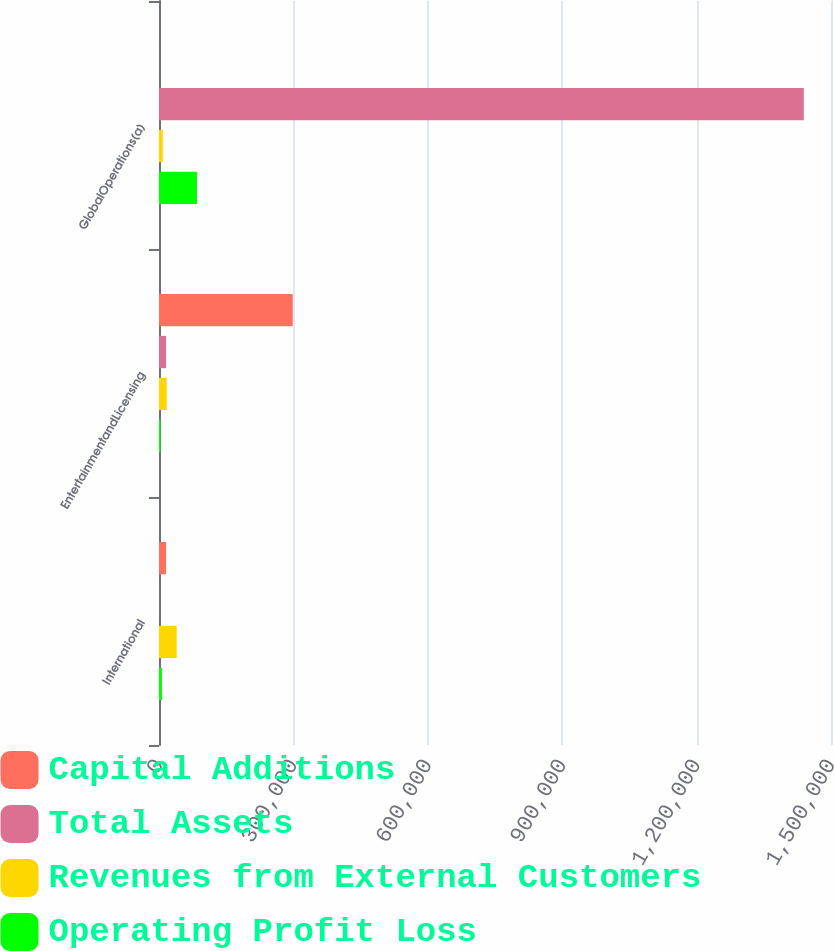Convert chart to OTSL. <chart><loc_0><loc_0><loc_500><loc_500><stacked_bar_chart><ecel><fcel>International<fcel>EntertainmentandLicensing<fcel>GlobalOperations(a)<nl><fcel>Capital Additions<fcel>15796<fcel>298540<fcel>109<nl><fcel>Total Assets<fcel>290<fcel>15796<fcel>1.43929e+06<nl><fcel>Revenues from External Customers<fcel>39470<fcel>17311<fcel>8415<nl><fcel>Operating Profit Loss<fcel>6530<fcel>3419<fcel>84759<nl></chart> 